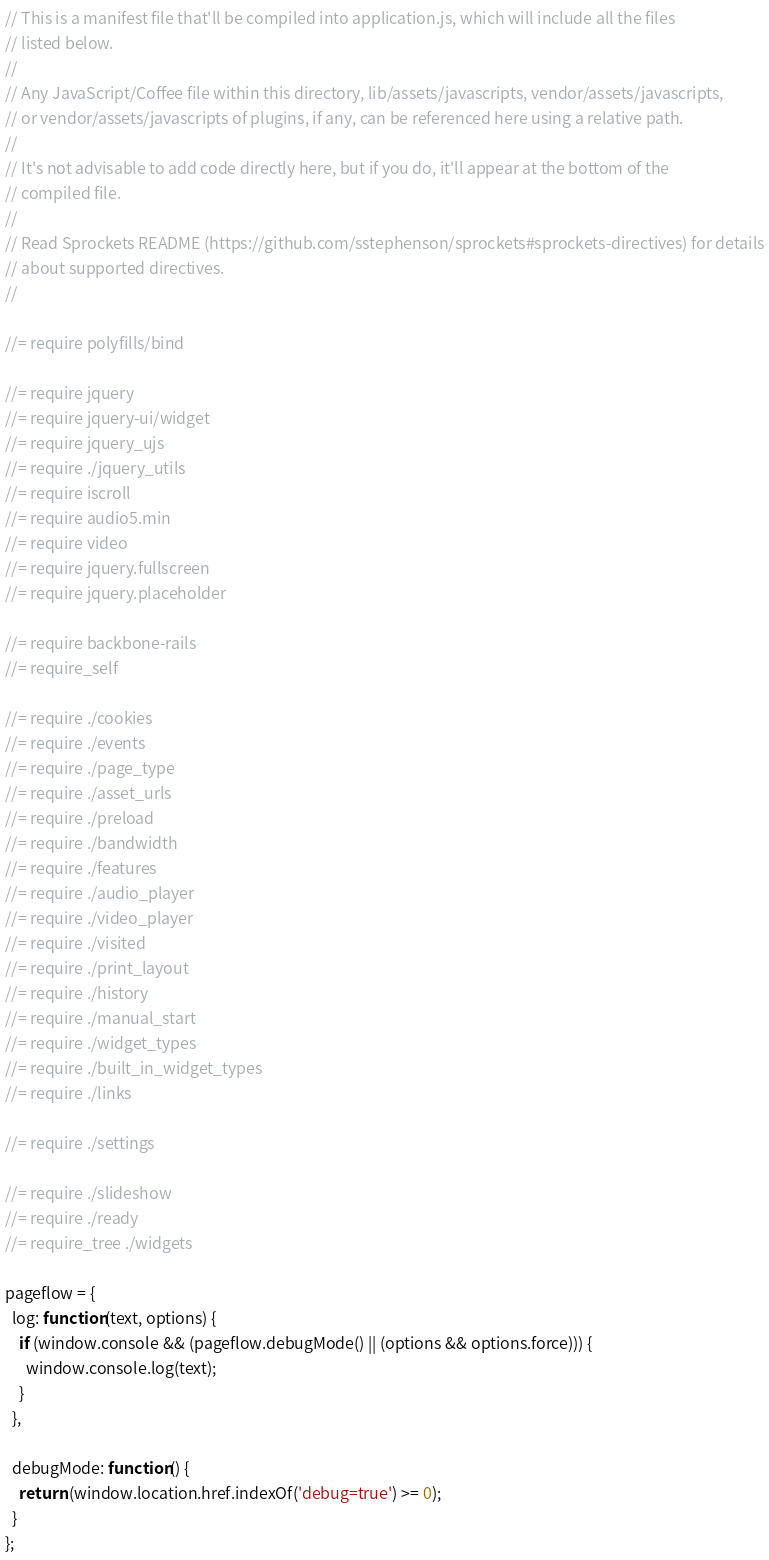Convert code to text. <code><loc_0><loc_0><loc_500><loc_500><_JavaScript_>// This is a manifest file that'll be compiled into application.js, which will include all the files
// listed below.
//
// Any JavaScript/Coffee file within this directory, lib/assets/javascripts, vendor/assets/javascripts,
// or vendor/assets/javascripts of plugins, if any, can be referenced here using a relative path.
//
// It's not advisable to add code directly here, but if you do, it'll appear at the bottom of the
// compiled file.
//
// Read Sprockets README (https://github.com/sstephenson/sprockets#sprockets-directives) for details
// about supported directives.
//

//= require polyfills/bind

//= require jquery
//= require jquery-ui/widget
//= require jquery_ujs
//= require ./jquery_utils
//= require iscroll
//= require audio5.min
//= require video
//= require jquery.fullscreen
//= require jquery.placeholder

//= require backbone-rails
//= require_self

//= require ./cookies
//= require ./events
//= require ./page_type
//= require ./asset_urls
//= require ./preload
//= require ./bandwidth
//= require ./features
//= require ./audio_player
//= require ./video_player
//= require ./visited
//= require ./print_layout
//= require ./history
//= require ./manual_start
//= require ./widget_types
//= require ./built_in_widget_types
//= require ./links

//= require ./settings

//= require ./slideshow
//= require ./ready
//= require_tree ./widgets

pageflow = {
  log: function(text, options) {
    if (window.console && (pageflow.debugMode() || (options && options.force))) {
      window.console.log(text);
    }
  },

  debugMode: function() {
    return (window.location.href.indexOf('debug=true') >= 0);
  }
};
</code> 